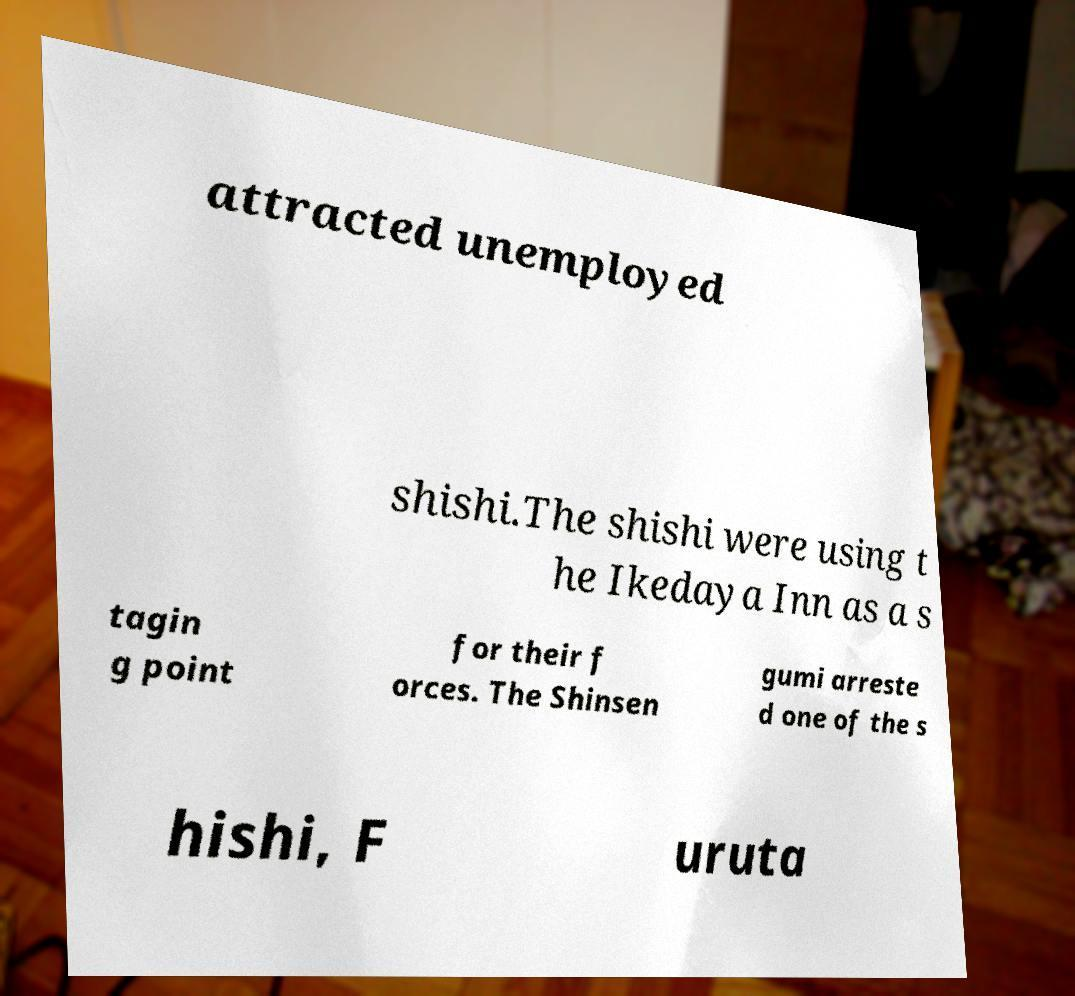Can you accurately transcribe the text from the provided image for me? attracted unemployed shishi.The shishi were using t he Ikedaya Inn as a s tagin g point for their f orces. The Shinsen gumi arreste d one of the s hishi, F uruta 